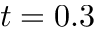Convert formula to latex. <formula><loc_0><loc_0><loc_500><loc_500>t = 0 . 3</formula> 